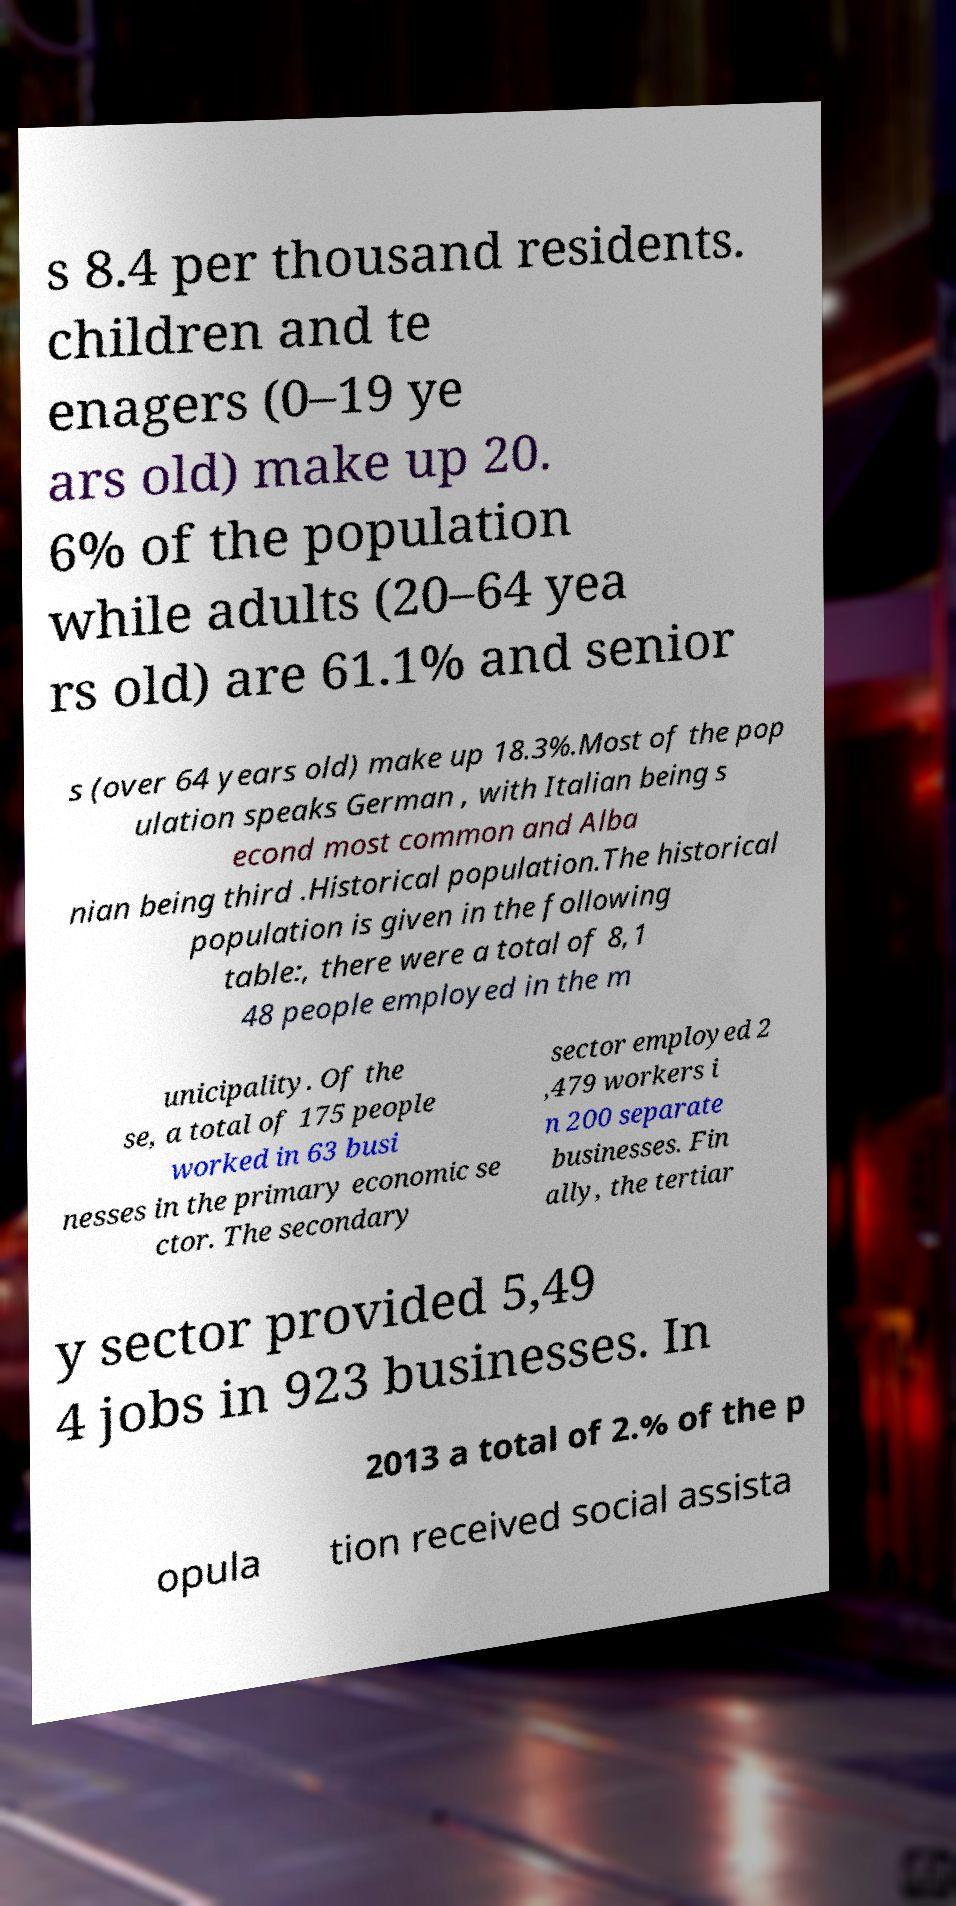There's text embedded in this image that I need extracted. Can you transcribe it verbatim? s 8.4 per thousand residents. children and te enagers (0–19 ye ars old) make up 20. 6% of the population while adults (20–64 yea rs old) are 61.1% and senior s (over 64 years old) make up 18.3%.Most of the pop ulation speaks German , with Italian being s econd most common and Alba nian being third .Historical population.The historical population is given in the following table:, there were a total of 8,1 48 people employed in the m unicipality. Of the se, a total of 175 people worked in 63 busi nesses in the primary economic se ctor. The secondary sector employed 2 ,479 workers i n 200 separate businesses. Fin ally, the tertiar y sector provided 5,49 4 jobs in 923 businesses. In 2013 a total of 2.% of the p opula tion received social assista 